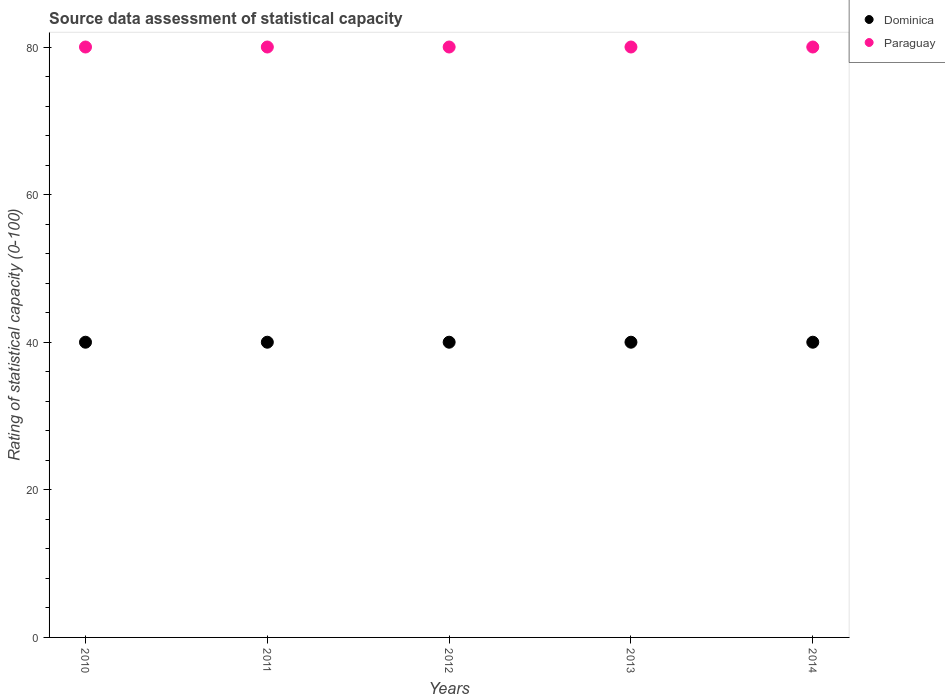What is the rating of statistical capacity in Paraguay in 2014?
Your response must be concise. 80. Across all years, what is the maximum rating of statistical capacity in Dominica?
Provide a short and direct response. 40. Across all years, what is the minimum rating of statistical capacity in Dominica?
Your answer should be very brief. 40. In which year was the rating of statistical capacity in Paraguay maximum?
Give a very brief answer. 2010. What is the difference between the rating of statistical capacity in Paraguay in 2012 and that in 2013?
Offer a terse response. 0. What is the difference between the rating of statistical capacity in Dominica in 2011 and the rating of statistical capacity in Paraguay in 2014?
Make the answer very short. -40. What is the average rating of statistical capacity in Dominica per year?
Provide a succinct answer. 40. In the year 2011, what is the difference between the rating of statistical capacity in Dominica and rating of statistical capacity in Paraguay?
Ensure brevity in your answer.  -40. Is the difference between the rating of statistical capacity in Dominica in 2013 and 2014 greater than the difference between the rating of statistical capacity in Paraguay in 2013 and 2014?
Provide a succinct answer. No. What is the difference between the highest and the lowest rating of statistical capacity in Dominica?
Your response must be concise. 0. Does the rating of statistical capacity in Dominica monotonically increase over the years?
Keep it short and to the point. No. How many dotlines are there?
Offer a very short reply. 2. Are the values on the major ticks of Y-axis written in scientific E-notation?
Provide a short and direct response. No. Where does the legend appear in the graph?
Your answer should be very brief. Top right. What is the title of the graph?
Provide a succinct answer. Source data assessment of statistical capacity. Does "Least developed countries" appear as one of the legend labels in the graph?
Make the answer very short. No. What is the label or title of the Y-axis?
Your response must be concise. Rating of statistical capacity (0-100). What is the Rating of statistical capacity (0-100) in Dominica in 2011?
Keep it short and to the point. 40. What is the Rating of statistical capacity (0-100) of Paraguay in 2011?
Your response must be concise. 80. What is the Rating of statistical capacity (0-100) in Dominica in 2012?
Offer a very short reply. 40. What is the Rating of statistical capacity (0-100) of Dominica in 2013?
Give a very brief answer. 40. Across all years, what is the maximum Rating of statistical capacity (0-100) in Dominica?
Your response must be concise. 40. Across all years, what is the maximum Rating of statistical capacity (0-100) in Paraguay?
Your response must be concise. 80. What is the difference between the Rating of statistical capacity (0-100) in Dominica in 2010 and that in 2011?
Ensure brevity in your answer.  0. What is the difference between the Rating of statistical capacity (0-100) of Paraguay in 2010 and that in 2011?
Offer a very short reply. 0. What is the difference between the Rating of statistical capacity (0-100) of Paraguay in 2010 and that in 2012?
Offer a terse response. 0. What is the difference between the Rating of statistical capacity (0-100) of Dominica in 2010 and that in 2013?
Your response must be concise. 0. What is the difference between the Rating of statistical capacity (0-100) in Dominica in 2010 and that in 2014?
Ensure brevity in your answer.  0. What is the difference between the Rating of statistical capacity (0-100) in Paraguay in 2010 and that in 2014?
Offer a terse response. 0. What is the difference between the Rating of statistical capacity (0-100) in Paraguay in 2011 and that in 2013?
Offer a terse response. 0. What is the difference between the Rating of statistical capacity (0-100) in Dominica in 2011 and that in 2014?
Your answer should be compact. 0. What is the difference between the Rating of statistical capacity (0-100) in Dominica in 2012 and that in 2014?
Make the answer very short. 0. What is the difference between the Rating of statistical capacity (0-100) in Paraguay in 2012 and that in 2014?
Your answer should be very brief. 0. What is the difference between the Rating of statistical capacity (0-100) of Dominica in 2010 and the Rating of statistical capacity (0-100) of Paraguay in 2013?
Offer a terse response. -40. What is the difference between the Rating of statistical capacity (0-100) in Dominica in 2011 and the Rating of statistical capacity (0-100) in Paraguay in 2013?
Give a very brief answer. -40. What is the difference between the Rating of statistical capacity (0-100) of Dominica in 2011 and the Rating of statistical capacity (0-100) of Paraguay in 2014?
Your response must be concise. -40. What is the difference between the Rating of statistical capacity (0-100) of Dominica in 2012 and the Rating of statistical capacity (0-100) of Paraguay in 2013?
Offer a terse response. -40. What is the difference between the Rating of statistical capacity (0-100) in Dominica in 2012 and the Rating of statistical capacity (0-100) in Paraguay in 2014?
Ensure brevity in your answer.  -40. What is the difference between the Rating of statistical capacity (0-100) in Dominica in 2013 and the Rating of statistical capacity (0-100) in Paraguay in 2014?
Provide a succinct answer. -40. What is the average Rating of statistical capacity (0-100) of Paraguay per year?
Your response must be concise. 80. In the year 2010, what is the difference between the Rating of statistical capacity (0-100) of Dominica and Rating of statistical capacity (0-100) of Paraguay?
Your answer should be very brief. -40. In the year 2011, what is the difference between the Rating of statistical capacity (0-100) of Dominica and Rating of statistical capacity (0-100) of Paraguay?
Offer a terse response. -40. In the year 2013, what is the difference between the Rating of statistical capacity (0-100) in Dominica and Rating of statistical capacity (0-100) in Paraguay?
Keep it short and to the point. -40. What is the ratio of the Rating of statistical capacity (0-100) of Dominica in 2010 to that in 2011?
Keep it short and to the point. 1. What is the ratio of the Rating of statistical capacity (0-100) in Paraguay in 2010 to that in 2011?
Keep it short and to the point. 1. What is the ratio of the Rating of statistical capacity (0-100) in Paraguay in 2010 to that in 2012?
Provide a succinct answer. 1. What is the ratio of the Rating of statistical capacity (0-100) of Dominica in 2010 to that in 2013?
Offer a terse response. 1. What is the ratio of the Rating of statistical capacity (0-100) in Paraguay in 2010 to that in 2014?
Ensure brevity in your answer.  1. What is the ratio of the Rating of statistical capacity (0-100) of Paraguay in 2011 to that in 2012?
Offer a terse response. 1. What is the ratio of the Rating of statistical capacity (0-100) in Paraguay in 2011 to that in 2013?
Offer a terse response. 1. What is the ratio of the Rating of statistical capacity (0-100) of Dominica in 2011 to that in 2014?
Provide a succinct answer. 1. What is the ratio of the Rating of statistical capacity (0-100) of Paraguay in 2011 to that in 2014?
Your response must be concise. 1. What is the ratio of the Rating of statistical capacity (0-100) in Paraguay in 2012 to that in 2013?
Offer a very short reply. 1. What is the ratio of the Rating of statistical capacity (0-100) in Paraguay in 2012 to that in 2014?
Ensure brevity in your answer.  1. What is the ratio of the Rating of statistical capacity (0-100) of Paraguay in 2013 to that in 2014?
Your answer should be compact. 1. What is the difference between the highest and the second highest Rating of statistical capacity (0-100) of Dominica?
Offer a terse response. 0. What is the difference between the highest and the lowest Rating of statistical capacity (0-100) of Dominica?
Give a very brief answer. 0. 